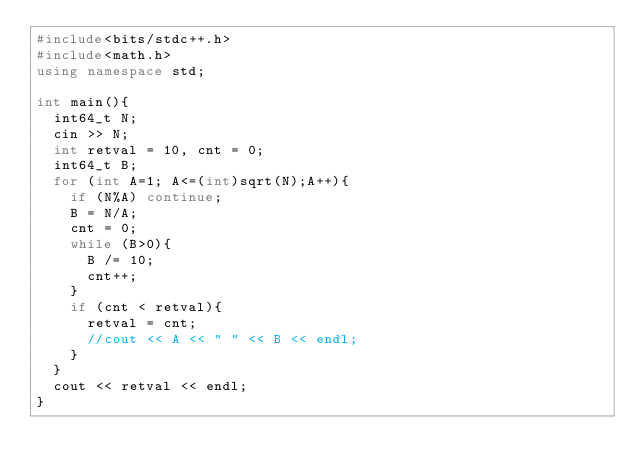Convert code to text. <code><loc_0><loc_0><loc_500><loc_500><_C++_>#include<bits/stdc++.h>
#include<math.h>
using namespace std;
 
int main(){
  int64_t N;
  cin >> N;
  int retval = 10, cnt = 0;
  int64_t B;
  for (int A=1; A<=(int)sqrt(N);A++){
    if (N%A) continue;
    B = N/A;
    cnt = 0;
    while (B>0){
      B /= 10;
      cnt++;
    }
    if (cnt < retval){
      retval = cnt;
      //cout << A << " " << B << endl;
    }
  }
  cout << retval << endl;
}
 </code> 